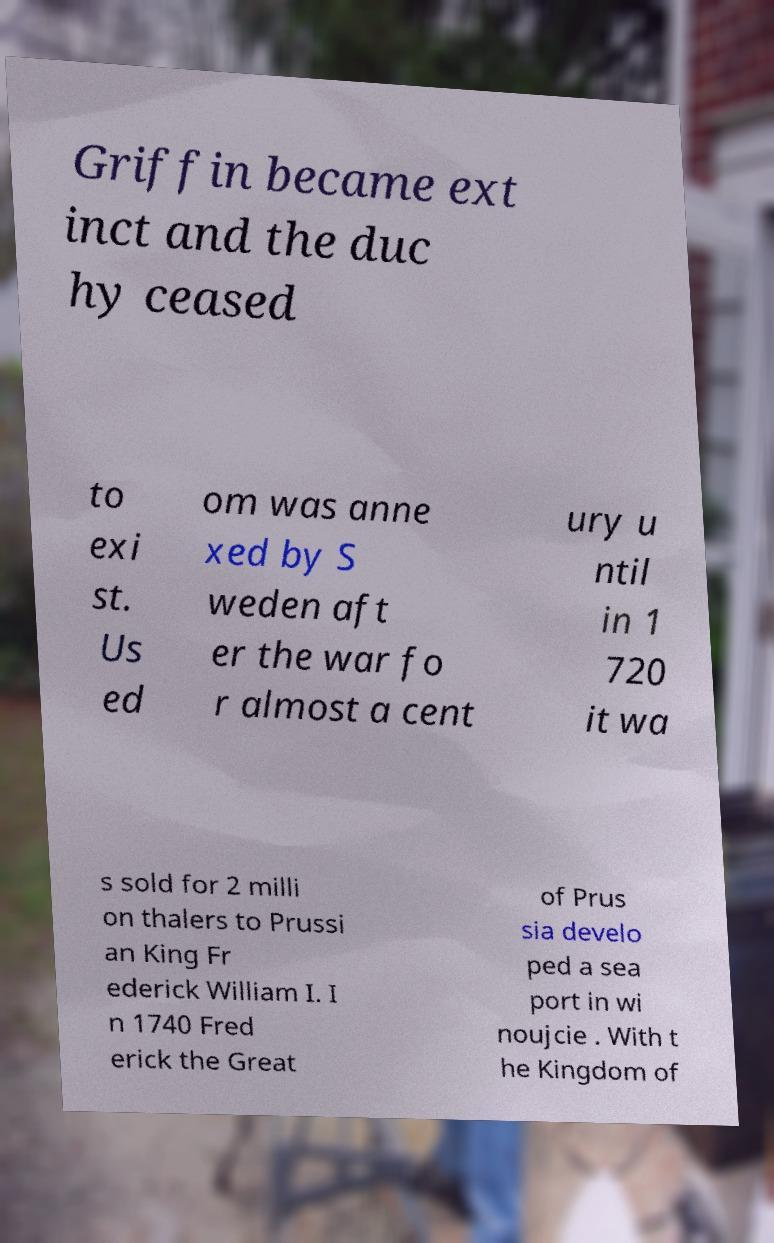What messages or text are displayed in this image? I need them in a readable, typed format. Griffin became ext inct and the duc hy ceased to exi st. Us ed om was anne xed by S weden aft er the war fo r almost a cent ury u ntil in 1 720 it wa s sold for 2 milli on thalers to Prussi an King Fr ederick William I. I n 1740 Fred erick the Great of Prus sia develo ped a sea port in wi noujcie . With t he Kingdom of 